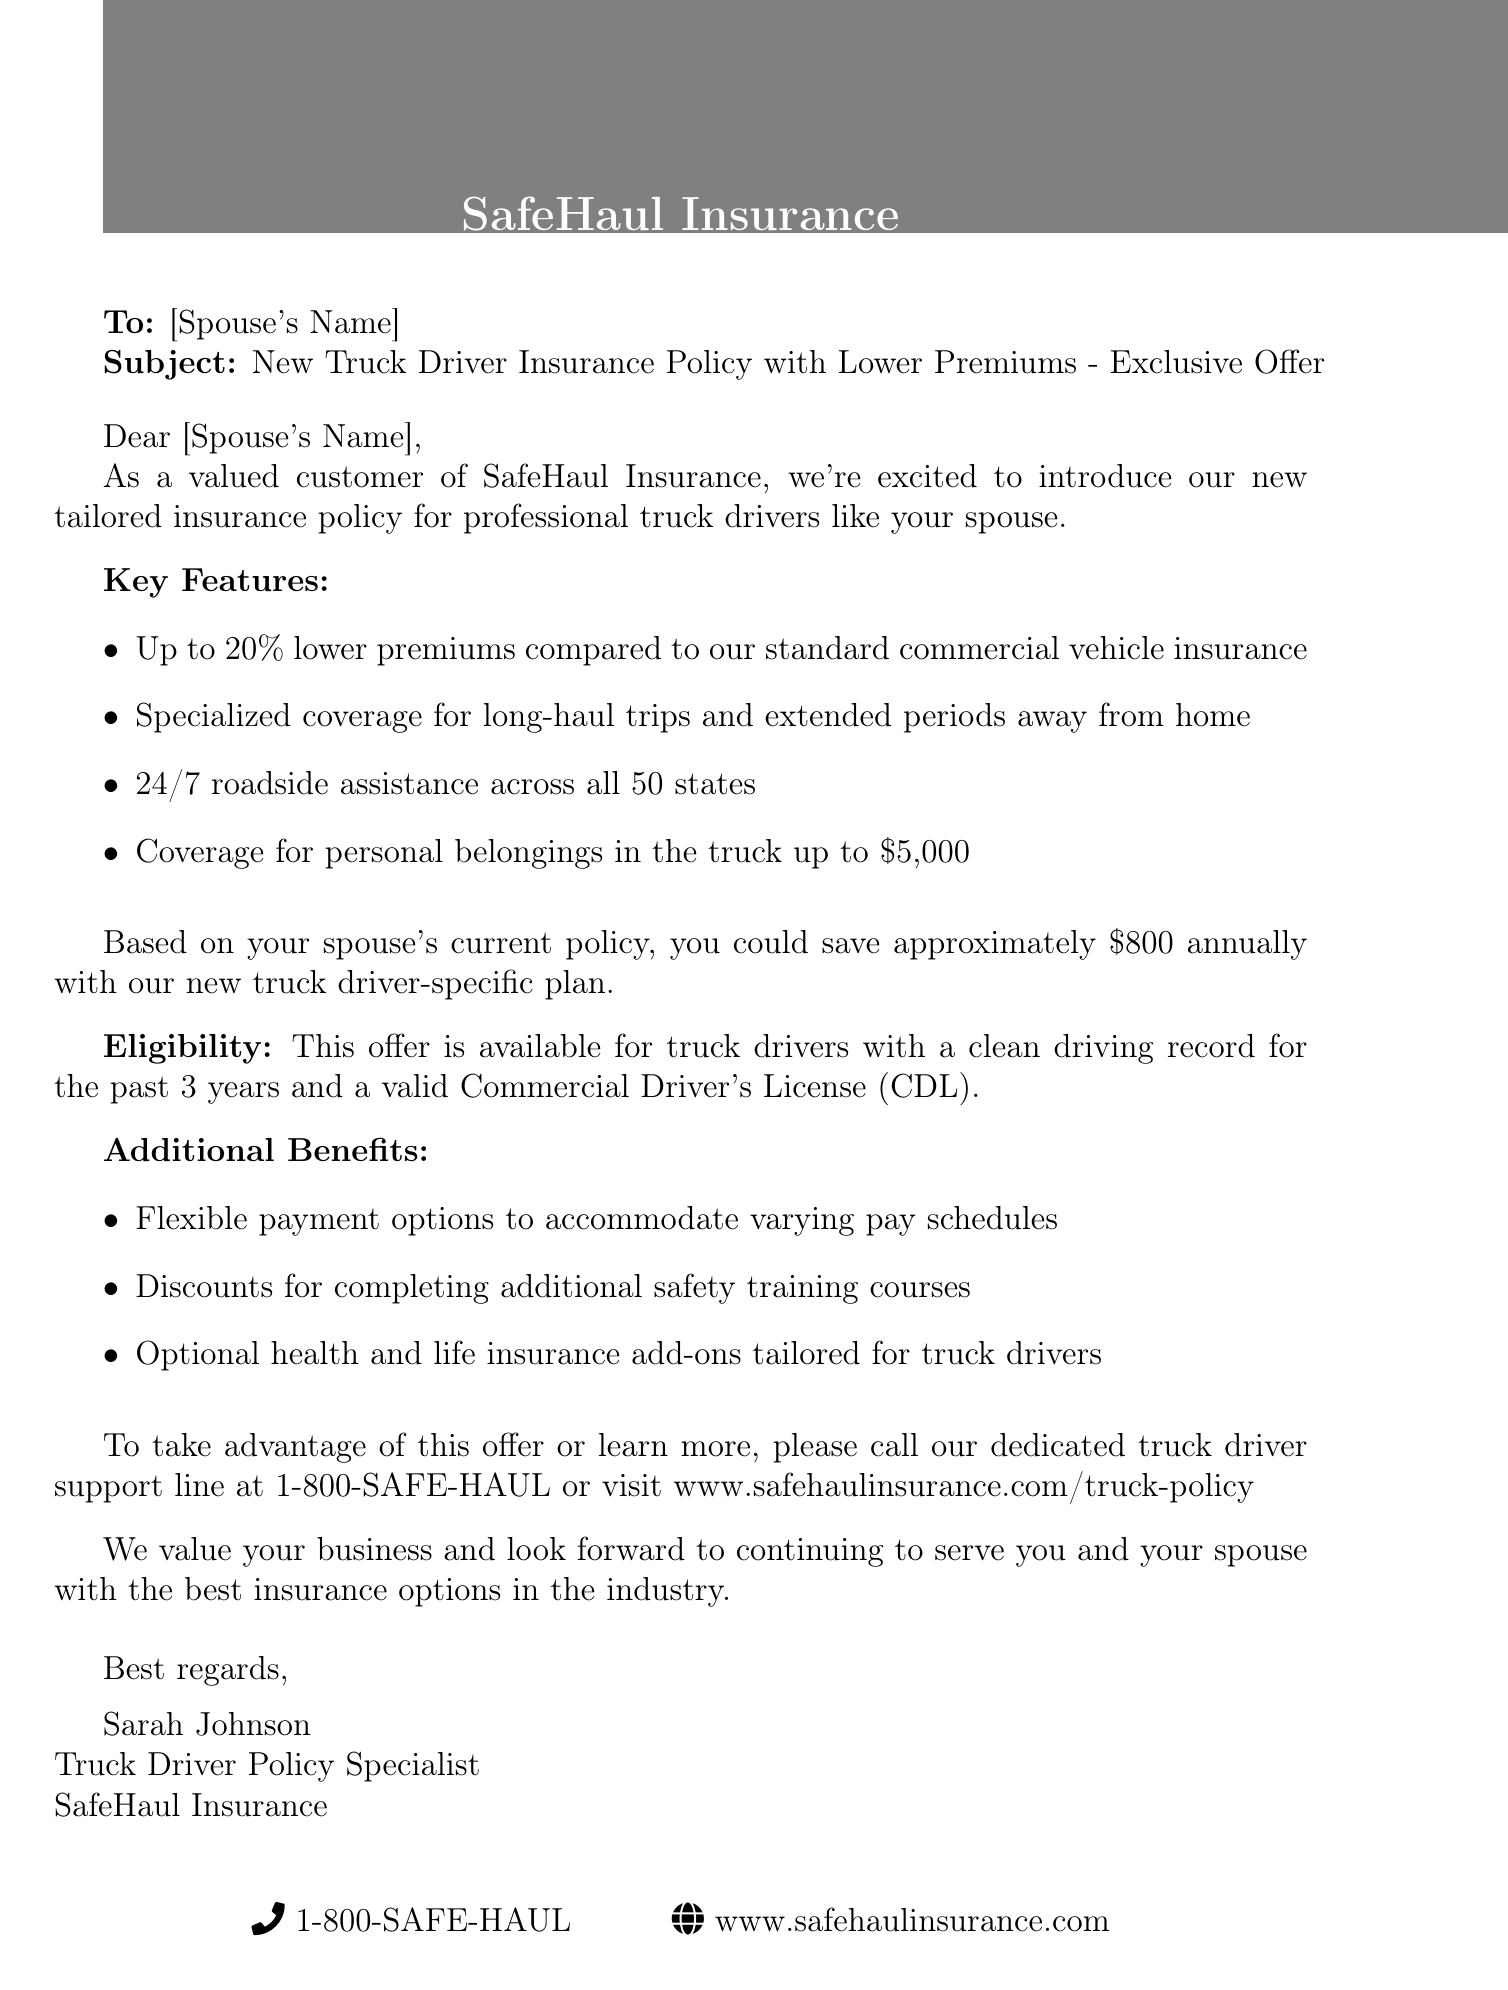What is the name of the insurance company? The email states that the insurance company is SafeHaul Insurance.
Answer: SafeHaul Insurance What is the percentage of lower premiums compared to standard insurance? The offer mentions premiums are "Up to 20% lower" than standard commercial vehicle insurance.
Answer: 20% What is the coverage for personal belongings in the truck? The email specifies coverage for personal belongings in the truck is "up to $5,000."
Answer: $5,000 How much could you save annually with the new plan? Based on the information, the potential savings are "approximately $800 annually."
Answer: $800 Who is the contact person for the insurance policy? The document provides the contact person’s name as Sarah Johnson.
Answer: Sarah Johnson What type of driver's license is needed for eligibility? The eligibility requirement mentions the need for a valid Commercial Driver's License (CDL).
Answer: Commercial Driver's License (CDL) What is one additional benefit listed in the email? The email lists "Flexible payment options" as one of the additional benefits.
Answer: Flexible payment options What should you do to take advantage of this offer? The email suggests calling the dedicated support line or visiting the website.
Answer: Call the support line or visit the website 